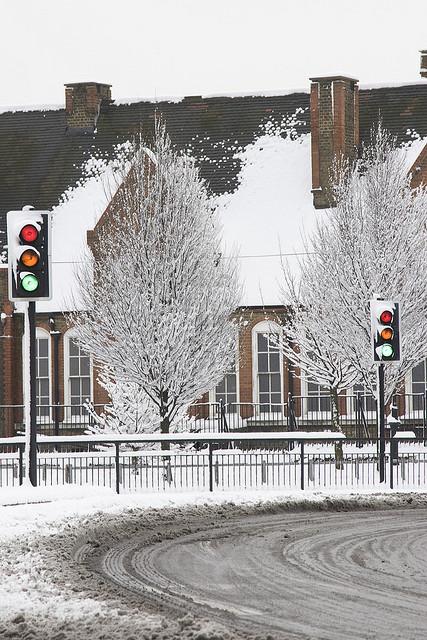Can this be a dangerous turn during icy weather?
Write a very short answer. Yes. What color are the traffic lights on?
Give a very brief answer. Green. Is it sunny and warm outside?
Concise answer only. No. 